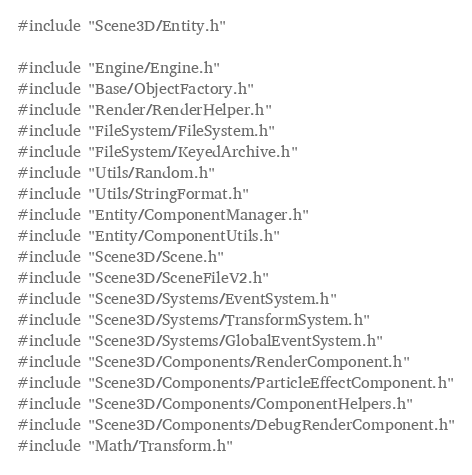<code> <loc_0><loc_0><loc_500><loc_500><_C++_>#include "Scene3D/Entity.h"

#include "Engine/Engine.h"
#include "Base/ObjectFactory.h"
#include "Render/RenderHelper.h"
#include "FileSystem/FileSystem.h"
#include "FileSystem/KeyedArchive.h"
#include "Utils/Random.h"
#include "Utils/StringFormat.h"
#include "Entity/ComponentManager.h"
#include "Entity/ComponentUtils.h"
#include "Scene3D/Scene.h"
#include "Scene3D/SceneFileV2.h"
#include "Scene3D/Systems/EventSystem.h"
#include "Scene3D/Systems/TransformSystem.h"
#include "Scene3D/Systems/GlobalEventSystem.h"
#include "Scene3D/Components/RenderComponent.h"
#include "Scene3D/Components/ParticleEffectComponent.h"
#include "Scene3D/Components/ComponentHelpers.h"
#include "Scene3D/Components/DebugRenderComponent.h"
#include "Math/Transform.h"</code> 